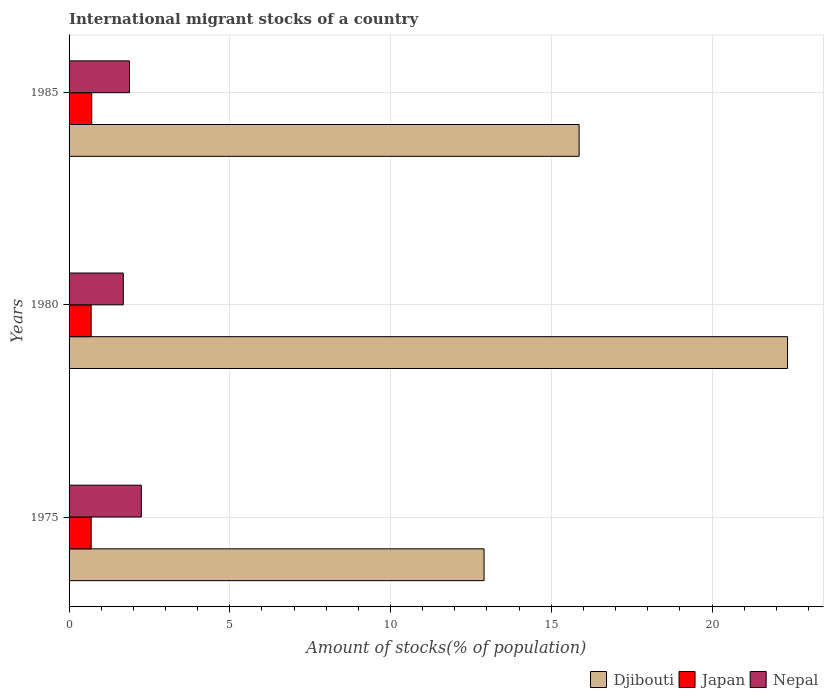How many different coloured bars are there?
Provide a short and direct response. 3. Are the number of bars per tick equal to the number of legend labels?
Your answer should be very brief. Yes. Are the number of bars on each tick of the Y-axis equal?
Make the answer very short. Yes. How many bars are there on the 3rd tick from the top?
Make the answer very short. 3. What is the label of the 3rd group of bars from the top?
Offer a very short reply. 1975. What is the amount of stocks in in Nepal in 1985?
Offer a very short reply. 1.88. Across all years, what is the maximum amount of stocks in in Japan?
Offer a very short reply. 0.7. Across all years, what is the minimum amount of stocks in in Nepal?
Your answer should be compact. 1.69. What is the total amount of stocks in in Japan in the graph?
Keep it short and to the point. 2.08. What is the difference between the amount of stocks in in Nepal in 1975 and that in 1985?
Make the answer very short. 0.37. What is the difference between the amount of stocks in in Japan in 1980 and the amount of stocks in in Djibouti in 1985?
Give a very brief answer. -15.18. What is the average amount of stocks in in Nepal per year?
Offer a very short reply. 1.94. In the year 1985, what is the difference between the amount of stocks in in Djibouti and amount of stocks in in Nepal?
Offer a very short reply. 13.99. In how many years, is the amount of stocks in in Japan greater than 13 %?
Make the answer very short. 0. What is the ratio of the amount of stocks in in Nepal in 1975 to that in 1980?
Provide a short and direct response. 1.33. What is the difference between the highest and the second highest amount of stocks in in Nepal?
Offer a very short reply. 0.37. What is the difference between the highest and the lowest amount of stocks in in Djibouti?
Ensure brevity in your answer.  9.44. In how many years, is the amount of stocks in in Djibouti greater than the average amount of stocks in in Djibouti taken over all years?
Give a very brief answer. 1. Is the sum of the amount of stocks in in Djibouti in 1975 and 1985 greater than the maximum amount of stocks in in Nepal across all years?
Ensure brevity in your answer.  Yes. What does the 2nd bar from the top in 1980 represents?
Provide a short and direct response. Japan. What does the 3rd bar from the bottom in 1980 represents?
Provide a succinct answer. Nepal. Are all the bars in the graph horizontal?
Your response must be concise. Yes. How many years are there in the graph?
Offer a very short reply. 3. What is the difference between two consecutive major ticks on the X-axis?
Ensure brevity in your answer.  5. Does the graph contain any zero values?
Provide a succinct answer. No. Where does the legend appear in the graph?
Your answer should be very brief. Bottom right. How many legend labels are there?
Give a very brief answer. 3. What is the title of the graph?
Your response must be concise. International migrant stocks of a country. Does "Turks and Caicos Islands" appear as one of the legend labels in the graph?
Give a very brief answer. No. What is the label or title of the X-axis?
Your response must be concise. Amount of stocks(% of population). What is the Amount of stocks(% of population) in Djibouti in 1975?
Keep it short and to the point. 12.91. What is the Amount of stocks(% of population) in Japan in 1975?
Give a very brief answer. 0.69. What is the Amount of stocks(% of population) in Nepal in 1975?
Ensure brevity in your answer.  2.25. What is the Amount of stocks(% of population) in Djibouti in 1980?
Your answer should be very brief. 22.35. What is the Amount of stocks(% of population) of Japan in 1980?
Your answer should be compact. 0.69. What is the Amount of stocks(% of population) of Nepal in 1980?
Keep it short and to the point. 1.69. What is the Amount of stocks(% of population) in Djibouti in 1985?
Provide a short and direct response. 15.87. What is the Amount of stocks(% of population) in Japan in 1985?
Your answer should be compact. 0.7. What is the Amount of stocks(% of population) in Nepal in 1985?
Your response must be concise. 1.88. Across all years, what is the maximum Amount of stocks(% of population) in Djibouti?
Your answer should be compact. 22.35. Across all years, what is the maximum Amount of stocks(% of population) of Japan?
Offer a terse response. 0.7. Across all years, what is the maximum Amount of stocks(% of population) in Nepal?
Your response must be concise. 2.25. Across all years, what is the minimum Amount of stocks(% of population) of Djibouti?
Make the answer very short. 12.91. Across all years, what is the minimum Amount of stocks(% of population) of Japan?
Offer a very short reply. 0.69. Across all years, what is the minimum Amount of stocks(% of population) of Nepal?
Ensure brevity in your answer.  1.69. What is the total Amount of stocks(% of population) of Djibouti in the graph?
Make the answer very short. 51.13. What is the total Amount of stocks(% of population) in Japan in the graph?
Your answer should be compact. 2.08. What is the total Amount of stocks(% of population) of Nepal in the graph?
Keep it short and to the point. 5.81. What is the difference between the Amount of stocks(% of population) of Djibouti in 1975 and that in 1980?
Ensure brevity in your answer.  -9.44. What is the difference between the Amount of stocks(% of population) in Japan in 1975 and that in 1980?
Your answer should be compact. 0. What is the difference between the Amount of stocks(% of population) of Nepal in 1975 and that in 1980?
Your answer should be compact. 0.56. What is the difference between the Amount of stocks(% of population) of Djibouti in 1975 and that in 1985?
Your response must be concise. -2.96. What is the difference between the Amount of stocks(% of population) in Japan in 1975 and that in 1985?
Offer a very short reply. -0.02. What is the difference between the Amount of stocks(% of population) in Nepal in 1975 and that in 1985?
Your answer should be very brief. 0.37. What is the difference between the Amount of stocks(% of population) of Djibouti in 1980 and that in 1985?
Provide a short and direct response. 6.48. What is the difference between the Amount of stocks(% of population) in Japan in 1980 and that in 1985?
Make the answer very short. -0.02. What is the difference between the Amount of stocks(% of population) of Nepal in 1980 and that in 1985?
Make the answer very short. -0.19. What is the difference between the Amount of stocks(% of population) of Djibouti in 1975 and the Amount of stocks(% of population) of Japan in 1980?
Make the answer very short. 12.22. What is the difference between the Amount of stocks(% of population) in Djibouti in 1975 and the Amount of stocks(% of population) in Nepal in 1980?
Provide a succinct answer. 11.22. What is the difference between the Amount of stocks(% of population) in Japan in 1975 and the Amount of stocks(% of population) in Nepal in 1980?
Offer a terse response. -1. What is the difference between the Amount of stocks(% of population) of Djibouti in 1975 and the Amount of stocks(% of population) of Japan in 1985?
Make the answer very short. 12.21. What is the difference between the Amount of stocks(% of population) in Djibouti in 1975 and the Amount of stocks(% of population) in Nepal in 1985?
Keep it short and to the point. 11.03. What is the difference between the Amount of stocks(% of population) of Japan in 1975 and the Amount of stocks(% of population) of Nepal in 1985?
Provide a succinct answer. -1.19. What is the difference between the Amount of stocks(% of population) in Djibouti in 1980 and the Amount of stocks(% of population) in Japan in 1985?
Give a very brief answer. 21.65. What is the difference between the Amount of stocks(% of population) of Djibouti in 1980 and the Amount of stocks(% of population) of Nepal in 1985?
Provide a short and direct response. 20.47. What is the difference between the Amount of stocks(% of population) in Japan in 1980 and the Amount of stocks(% of population) in Nepal in 1985?
Your answer should be compact. -1.19. What is the average Amount of stocks(% of population) in Djibouti per year?
Make the answer very short. 17.04. What is the average Amount of stocks(% of population) of Japan per year?
Your response must be concise. 0.69. What is the average Amount of stocks(% of population) in Nepal per year?
Your answer should be very brief. 1.94. In the year 1975, what is the difference between the Amount of stocks(% of population) of Djibouti and Amount of stocks(% of population) of Japan?
Make the answer very short. 12.22. In the year 1975, what is the difference between the Amount of stocks(% of population) of Djibouti and Amount of stocks(% of population) of Nepal?
Give a very brief answer. 10.66. In the year 1975, what is the difference between the Amount of stocks(% of population) of Japan and Amount of stocks(% of population) of Nepal?
Your answer should be very brief. -1.56. In the year 1980, what is the difference between the Amount of stocks(% of population) of Djibouti and Amount of stocks(% of population) of Japan?
Give a very brief answer. 21.66. In the year 1980, what is the difference between the Amount of stocks(% of population) in Djibouti and Amount of stocks(% of population) in Nepal?
Your answer should be compact. 20.66. In the year 1980, what is the difference between the Amount of stocks(% of population) of Japan and Amount of stocks(% of population) of Nepal?
Keep it short and to the point. -1. In the year 1985, what is the difference between the Amount of stocks(% of population) of Djibouti and Amount of stocks(% of population) of Japan?
Your answer should be compact. 15.16. In the year 1985, what is the difference between the Amount of stocks(% of population) of Djibouti and Amount of stocks(% of population) of Nepal?
Make the answer very short. 13.99. In the year 1985, what is the difference between the Amount of stocks(% of population) of Japan and Amount of stocks(% of population) of Nepal?
Provide a succinct answer. -1.17. What is the ratio of the Amount of stocks(% of population) of Djibouti in 1975 to that in 1980?
Offer a terse response. 0.58. What is the ratio of the Amount of stocks(% of population) of Nepal in 1975 to that in 1980?
Your answer should be very brief. 1.33. What is the ratio of the Amount of stocks(% of population) in Djibouti in 1975 to that in 1985?
Ensure brevity in your answer.  0.81. What is the ratio of the Amount of stocks(% of population) in Japan in 1975 to that in 1985?
Provide a short and direct response. 0.98. What is the ratio of the Amount of stocks(% of population) in Nepal in 1975 to that in 1985?
Provide a short and direct response. 1.2. What is the ratio of the Amount of stocks(% of population) in Djibouti in 1980 to that in 1985?
Ensure brevity in your answer.  1.41. What is the ratio of the Amount of stocks(% of population) of Japan in 1980 to that in 1985?
Provide a succinct answer. 0.98. What is the ratio of the Amount of stocks(% of population) in Nepal in 1980 to that in 1985?
Provide a succinct answer. 0.9. What is the difference between the highest and the second highest Amount of stocks(% of population) in Djibouti?
Your response must be concise. 6.48. What is the difference between the highest and the second highest Amount of stocks(% of population) in Japan?
Make the answer very short. 0.02. What is the difference between the highest and the second highest Amount of stocks(% of population) in Nepal?
Offer a very short reply. 0.37. What is the difference between the highest and the lowest Amount of stocks(% of population) in Djibouti?
Your answer should be very brief. 9.44. What is the difference between the highest and the lowest Amount of stocks(% of population) of Japan?
Provide a succinct answer. 0.02. What is the difference between the highest and the lowest Amount of stocks(% of population) of Nepal?
Keep it short and to the point. 0.56. 